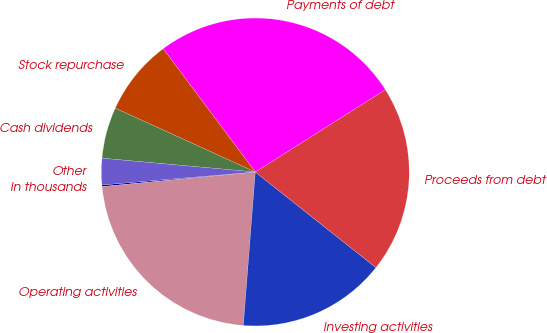<chart> <loc_0><loc_0><loc_500><loc_500><pie_chart><fcel>In thousands<fcel>Operating activities<fcel>Investing activities<fcel>Proceeds from debt<fcel>Payments of debt<fcel>Stock repurchase<fcel>Cash dividends<fcel>Other<nl><fcel>0.17%<fcel>22.25%<fcel>15.57%<fcel>19.65%<fcel>26.22%<fcel>7.98%<fcel>5.38%<fcel>2.77%<nl></chart> 